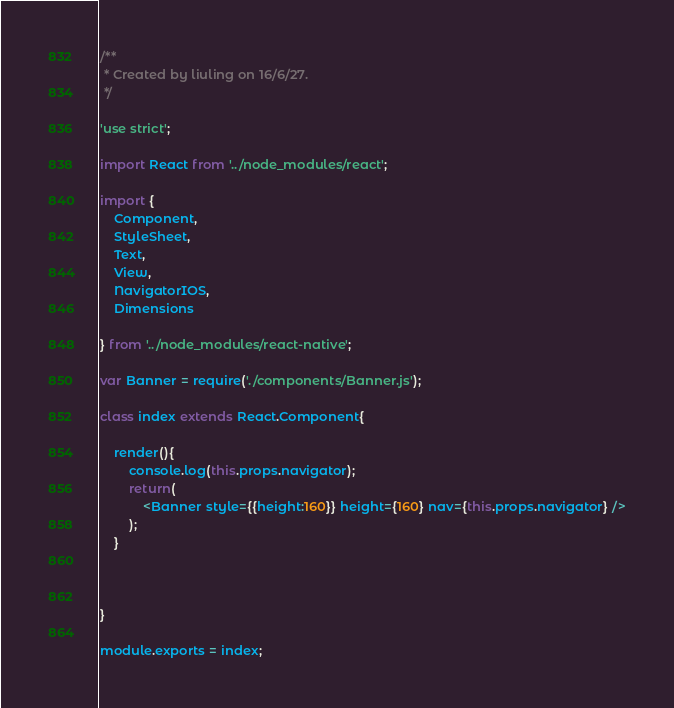Convert code to text. <code><loc_0><loc_0><loc_500><loc_500><_JavaScript_>/**
 * Created by liuling on 16/6/27.
 */

'use strict';

import React from '../node_modules/react';

import {
    Component,
    StyleSheet,
    Text,
    View,
    NavigatorIOS,
    Dimensions

} from '../node_modules/react-native';

var Banner = require('./components/Banner.js');

class index extends React.Component{

    render(){
        console.log(this.props.navigator);
        return(
            <Banner style={{height:160}} height={160} nav={this.props.navigator} />
        );
    }



}

module.exports = index;</code> 